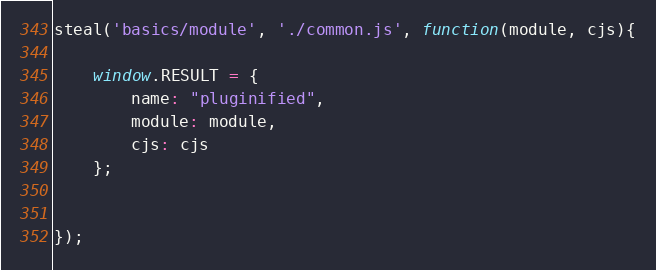Convert code to text. <code><loc_0><loc_0><loc_500><loc_500><_JavaScript_>steal('basics/module', './common.js', function(module, cjs){
	
	window.RESULT = {
		name: "pluginified",
		module: module,
		cjs: cjs
	};

	
});
</code> 